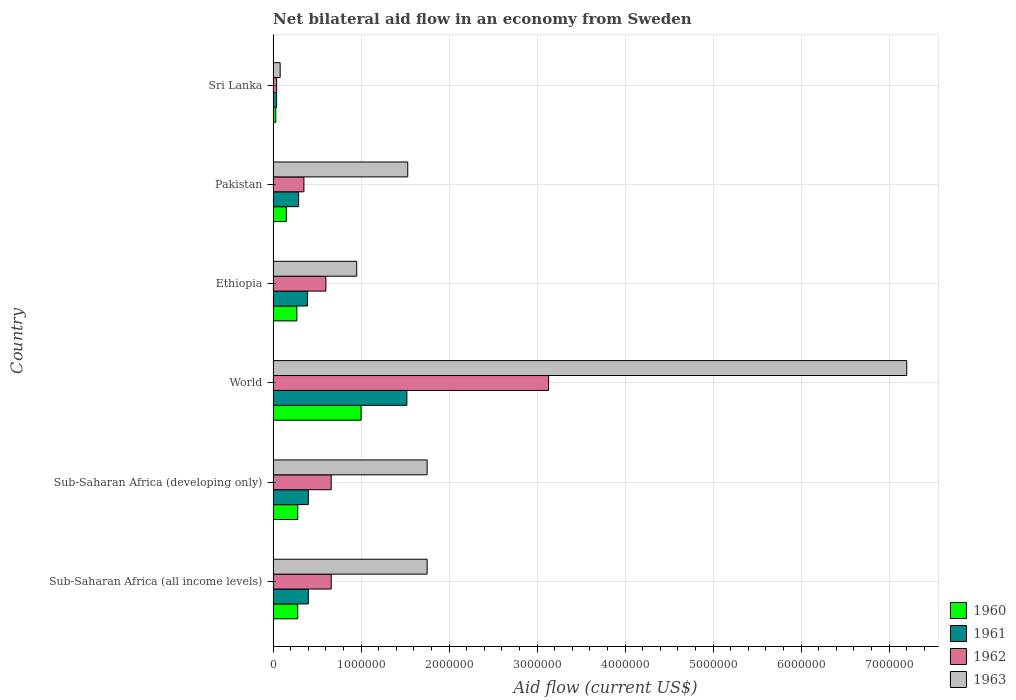How many different coloured bars are there?
Offer a terse response. 4. Are the number of bars per tick equal to the number of legend labels?
Offer a terse response. Yes. What is the label of the 6th group of bars from the top?
Your response must be concise. Sub-Saharan Africa (all income levels). In how many cases, is the number of bars for a given country not equal to the number of legend labels?
Provide a short and direct response. 0. What is the net bilateral aid flow in 1963 in Ethiopia?
Ensure brevity in your answer.  9.50e+05. Across all countries, what is the maximum net bilateral aid flow in 1960?
Make the answer very short. 1.00e+06. In which country was the net bilateral aid flow in 1961 minimum?
Your response must be concise. Sri Lanka. What is the total net bilateral aid flow in 1960 in the graph?
Give a very brief answer. 2.01e+06. What is the difference between the net bilateral aid flow in 1961 in Sri Lanka and that in Sub-Saharan Africa (developing only)?
Make the answer very short. -3.60e+05. What is the difference between the net bilateral aid flow in 1963 in Sri Lanka and the net bilateral aid flow in 1962 in Ethiopia?
Your answer should be compact. -5.20e+05. What is the average net bilateral aid flow in 1960 per country?
Your response must be concise. 3.35e+05. What is the ratio of the net bilateral aid flow in 1960 in Sri Lanka to that in World?
Offer a very short reply. 0.03. Is the difference between the net bilateral aid flow in 1961 in Sri Lanka and World greater than the difference between the net bilateral aid flow in 1960 in Sri Lanka and World?
Give a very brief answer. No. What is the difference between the highest and the second highest net bilateral aid flow in 1962?
Ensure brevity in your answer.  2.47e+06. What is the difference between the highest and the lowest net bilateral aid flow in 1960?
Your answer should be very brief. 9.70e+05. In how many countries, is the net bilateral aid flow in 1962 greater than the average net bilateral aid flow in 1962 taken over all countries?
Make the answer very short. 1. What does the 3rd bar from the bottom in Sub-Saharan Africa (developing only) represents?
Provide a short and direct response. 1962. Is it the case that in every country, the sum of the net bilateral aid flow in 1960 and net bilateral aid flow in 1963 is greater than the net bilateral aid flow in 1962?
Provide a succinct answer. Yes. How many bars are there?
Your answer should be compact. 24. Are all the bars in the graph horizontal?
Keep it short and to the point. Yes. How many countries are there in the graph?
Offer a terse response. 6. What is the difference between two consecutive major ticks on the X-axis?
Make the answer very short. 1.00e+06. Are the values on the major ticks of X-axis written in scientific E-notation?
Your answer should be very brief. No. Does the graph contain any zero values?
Ensure brevity in your answer.  No. Where does the legend appear in the graph?
Your answer should be compact. Bottom right. How are the legend labels stacked?
Keep it short and to the point. Vertical. What is the title of the graph?
Your answer should be compact. Net bilateral aid flow in an economy from Sweden. Does "1990" appear as one of the legend labels in the graph?
Offer a very short reply. No. What is the label or title of the Y-axis?
Give a very brief answer. Country. What is the Aid flow (current US$) in 1962 in Sub-Saharan Africa (all income levels)?
Ensure brevity in your answer.  6.60e+05. What is the Aid flow (current US$) in 1963 in Sub-Saharan Africa (all income levels)?
Provide a short and direct response. 1.75e+06. What is the Aid flow (current US$) in 1960 in Sub-Saharan Africa (developing only)?
Make the answer very short. 2.80e+05. What is the Aid flow (current US$) in 1961 in Sub-Saharan Africa (developing only)?
Provide a short and direct response. 4.00e+05. What is the Aid flow (current US$) in 1963 in Sub-Saharan Africa (developing only)?
Ensure brevity in your answer.  1.75e+06. What is the Aid flow (current US$) of 1960 in World?
Give a very brief answer. 1.00e+06. What is the Aid flow (current US$) of 1961 in World?
Ensure brevity in your answer.  1.52e+06. What is the Aid flow (current US$) in 1962 in World?
Ensure brevity in your answer.  3.13e+06. What is the Aid flow (current US$) in 1963 in World?
Provide a short and direct response. 7.20e+06. What is the Aid flow (current US$) of 1960 in Ethiopia?
Provide a short and direct response. 2.70e+05. What is the Aid flow (current US$) in 1963 in Ethiopia?
Offer a very short reply. 9.50e+05. What is the Aid flow (current US$) of 1963 in Pakistan?
Offer a very short reply. 1.53e+06. Across all countries, what is the maximum Aid flow (current US$) of 1961?
Your answer should be compact. 1.52e+06. Across all countries, what is the maximum Aid flow (current US$) of 1962?
Provide a short and direct response. 3.13e+06. Across all countries, what is the maximum Aid flow (current US$) of 1963?
Offer a very short reply. 7.20e+06. Across all countries, what is the minimum Aid flow (current US$) in 1960?
Provide a succinct answer. 3.00e+04. Across all countries, what is the minimum Aid flow (current US$) in 1961?
Ensure brevity in your answer.  4.00e+04. Across all countries, what is the minimum Aid flow (current US$) in 1963?
Make the answer very short. 8.00e+04. What is the total Aid flow (current US$) of 1960 in the graph?
Offer a terse response. 2.01e+06. What is the total Aid flow (current US$) in 1961 in the graph?
Ensure brevity in your answer.  3.04e+06. What is the total Aid flow (current US$) of 1962 in the graph?
Your response must be concise. 5.44e+06. What is the total Aid flow (current US$) of 1963 in the graph?
Ensure brevity in your answer.  1.33e+07. What is the difference between the Aid flow (current US$) in 1960 in Sub-Saharan Africa (all income levels) and that in Sub-Saharan Africa (developing only)?
Your answer should be compact. 0. What is the difference between the Aid flow (current US$) of 1963 in Sub-Saharan Africa (all income levels) and that in Sub-Saharan Africa (developing only)?
Offer a very short reply. 0. What is the difference between the Aid flow (current US$) of 1960 in Sub-Saharan Africa (all income levels) and that in World?
Keep it short and to the point. -7.20e+05. What is the difference between the Aid flow (current US$) in 1961 in Sub-Saharan Africa (all income levels) and that in World?
Your answer should be very brief. -1.12e+06. What is the difference between the Aid flow (current US$) of 1962 in Sub-Saharan Africa (all income levels) and that in World?
Offer a very short reply. -2.47e+06. What is the difference between the Aid flow (current US$) of 1963 in Sub-Saharan Africa (all income levels) and that in World?
Offer a terse response. -5.45e+06. What is the difference between the Aid flow (current US$) of 1961 in Sub-Saharan Africa (all income levels) and that in Ethiopia?
Offer a terse response. 10000. What is the difference between the Aid flow (current US$) in 1962 in Sub-Saharan Africa (all income levels) and that in Ethiopia?
Keep it short and to the point. 6.00e+04. What is the difference between the Aid flow (current US$) in 1963 in Sub-Saharan Africa (all income levels) and that in Ethiopia?
Offer a very short reply. 8.00e+05. What is the difference between the Aid flow (current US$) in 1961 in Sub-Saharan Africa (all income levels) and that in Sri Lanka?
Give a very brief answer. 3.60e+05. What is the difference between the Aid flow (current US$) in 1962 in Sub-Saharan Africa (all income levels) and that in Sri Lanka?
Offer a very short reply. 6.20e+05. What is the difference between the Aid flow (current US$) in 1963 in Sub-Saharan Africa (all income levels) and that in Sri Lanka?
Make the answer very short. 1.67e+06. What is the difference between the Aid flow (current US$) of 1960 in Sub-Saharan Africa (developing only) and that in World?
Ensure brevity in your answer.  -7.20e+05. What is the difference between the Aid flow (current US$) in 1961 in Sub-Saharan Africa (developing only) and that in World?
Provide a succinct answer. -1.12e+06. What is the difference between the Aid flow (current US$) of 1962 in Sub-Saharan Africa (developing only) and that in World?
Ensure brevity in your answer.  -2.47e+06. What is the difference between the Aid flow (current US$) of 1963 in Sub-Saharan Africa (developing only) and that in World?
Provide a short and direct response. -5.45e+06. What is the difference between the Aid flow (current US$) in 1961 in Sub-Saharan Africa (developing only) and that in Ethiopia?
Your answer should be compact. 10000. What is the difference between the Aid flow (current US$) in 1962 in Sub-Saharan Africa (developing only) and that in Ethiopia?
Provide a succinct answer. 6.00e+04. What is the difference between the Aid flow (current US$) of 1963 in Sub-Saharan Africa (developing only) and that in Ethiopia?
Your answer should be compact. 8.00e+05. What is the difference between the Aid flow (current US$) in 1960 in Sub-Saharan Africa (developing only) and that in Pakistan?
Your answer should be very brief. 1.30e+05. What is the difference between the Aid flow (current US$) of 1962 in Sub-Saharan Africa (developing only) and that in Pakistan?
Keep it short and to the point. 3.10e+05. What is the difference between the Aid flow (current US$) in 1963 in Sub-Saharan Africa (developing only) and that in Pakistan?
Offer a terse response. 2.20e+05. What is the difference between the Aid flow (current US$) of 1962 in Sub-Saharan Africa (developing only) and that in Sri Lanka?
Ensure brevity in your answer.  6.20e+05. What is the difference between the Aid flow (current US$) in 1963 in Sub-Saharan Africa (developing only) and that in Sri Lanka?
Your answer should be compact. 1.67e+06. What is the difference between the Aid flow (current US$) of 1960 in World and that in Ethiopia?
Provide a succinct answer. 7.30e+05. What is the difference between the Aid flow (current US$) in 1961 in World and that in Ethiopia?
Provide a succinct answer. 1.13e+06. What is the difference between the Aid flow (current US$) of 1962 in World and that in Ethiopia?
Give a very brief answer. 2.53e+06. What is the difference between the Aid flow (current US$) of 1963 in World and that in Ethiopia?
Make the answer very short. 6.25e+06. What is the difference between the Aid flow (current US$) in 1960 in World and that in Pakistan?
Your answer should be very brief. 8.50e+05. What is the difference between the Aid flow (current US$) in 1961 in World and that in Pakistan?
Your answer should be very brief. 1.23e+06. What is the difference between the Aid flow (current US$) of 1962 in World and that in Pakistan?
Ensure brevity in your answer.  2.78e+06. What is the difference between the Aid flow (current US$) of 1963 in World and that in Pakistan?
Offer a terse response. 5.67e+06. What is the difference between the Aid flow (current US$) in 1960 in World and that in Sri Lanka?
Keep it short and to the point. 9.70e+05. What is the difference between the Aid flow (current US$) in 1961 in World and that in Sri Lanka?
Offer a terse response. 1.48e+06. What is the difference between the Aid flow (current US$) of 1962 in World and that in Sri Lanka?
Keep it short and to the point. 3.09e+06. What is the difference between the Aid flow (current US$) in 1963 in World and that in Sri Lanka?
Your response must be concise. 7.12e+06. What is the difference between the Aid flow (current US$) of 1960 in Ethiopia and that in Pakistan?
Provide a short and direct response. 1.20e+05. What is the difference between the Aid flow (current US$) in 1963 in Ethiopia and that in Pakistan?
Keep it short and to the point. -5.80e+05. What is the difference between the Aid flow (current US$) in 1960 in Ethiopia and that in Sri Lanka?
Keep it short and to the point. 2.40e+05. What is the difference between the Aid flow (current US$) in 1961 in Ethiopia and that in Sri Lanka?
Make the answer very short. 3.50e+05. What is the difference between the Aid flow (current US$) in 1962 in Ethiopia and that in Sri Lanka?
Provide a succinct answer. 5.60e+05. What is the difference between the Aid flow (current US$) of 1963 in Ethiopia and that in Sri Lanka?
Give a very brief answer. 8.70e+05. What is the difference between the Aid flow (current US$) of 1961 in Pakistan and that in Sri Lanka?
Make the answer very short. 2.50e+05. What is the difference between the Aid flow (current US$) in 1963 in Pakistan and that in Sri Lanka?
Give a very brief answer. 1.45e+06. What is the difference between the Aid flow (current US$) of 1960 in Sub-Saharan Africa (all income levels) and the Aid flow (current US$) of 1961 in Sub-Saharan Africa (developing only)?
Offer a terse response. -1.20e+05. What is the difference between the Aid flow (current US$) of 1960 in Sub-Saharan Africa (all income levels) and the Aid flow (current US$) of 1962 in Sub-Saharan Africa (developing only)?
Provide a short and direct response. -3.80e+05. What is the difference between the Aid flow (current US$) of 1960 in Sub-Saharan Africa (all income levels) and the Aid flow (current US$) of 1963 in Sub-Saharan Africa (developing only)?
Offer a terse response. -1.47e+06. What is the difference between the Aid flow (current US$) of 1961 in Sub-Saharan Africa (all income levels) and the Aid flow (current US$) of 1962 in Sub-Saharan Africa (developing only)?
Give a very brief answer. -2.60e+05. What is the difference between the Aid flow (current US$) in 1961 in Sub-Saharan Africa (all income levels) and the Aid flow (current US$) in 1963 in Sub-Saharan Africa (developing only)?
Make the answer very short. -1.35e+06. What is the difference between the Aid flow (current US$) in 1962 in Sub-Saharan Africa (all income levels) and the Aid flow (current US$) in 1963 in Sub-Saharan Africa (developing only)?
Keep it short and to the point. -1.09e+06. What is the difference between the Aid flow (current US$) in 1960 in Sub-Saharan Africa (all income levels) and the Aid flow (current US$) in 1961 in World?
Ensure brevity in your answer.  -1.24e+06. What is the difference between the Aid flow (current US$) of 1960 in Sub-Saharan Africa (all income levels) and the Aid flow (current US$) of 1962 in World?
Make the answer very short. -2.85e+06. What is the difference between the Aid flow (current US$) of 1960 in Sub-Saharan Africa (all income levels) and the Aid flow (current US$) of 1963 in World?
Provide a short and direct response. -6.92e+06. What is the difference between the Aid flow (current US$) in 1961 in Sub-Saharan Africa (all income levels) and the Aid flow (current US$) in 1962 in World?
Offer a terse response. -2.73e+06. What is the difference between the Aid flow (current US$) of 1961 in Sub-Saharan Africa (all income levels) and the Aid flow (current US$) of 1963 in World?
Give a very brief answer. -6.80e+06. What is the difference between the Aid flow (current US$) in 1962 in Sub-Saharan Africa (all income levels) and the Aid flow (current US$) in 1963 in World?
Offer a very short reply. -6.54e+06. What is the difference between the Aid flow (current US$) in 1960 in Sub-Saharan Africa (all income levels) and the Aid flow (current US$) in 1961 in Ethiopia?
Your answer should be very brief. -1.10e+05. What is the difference between the Aid flow (current US$) in 1960 in Sub-Saharan Africa (all income levels) and the Aid flow (current US$) in 1962 in Ethiopia?
Give a very brief answer. -3.20e+05. What is the difference between the Aid flow (current US$) of 1960 in Sub-Saharan Africa (all income levels) and the Aid flow (current US$) of 1963 in Ethiopia?
Provide a succinct answer. -6.70e+05. What is the difference between the Aid flow (current US$) in 1961 in Sub-Saharan Africa (all income levels) and the Aid flow (current US$) in 1962 in Ethiopia?
Offer a terse response. -2.00e+05. What is the difference between the Aid flow (current US$) of 1961 in Sub-Saharan Africa (all income levels) and the Aid flow (current US$) of 1963 in Ethiopia?
Ensure brevity in your answer.  -5.50e+05. What is the difference between the Aid flow (current US$) of 1960 in Sub-Saharan Africa (all income levels) and the Aid flow (current US$) of 1962 in Pakistan?
Your answer should be very brief. -7.00e+04. What is the difference between the Aid flow (current US$) in 1960 in Sub-Saharan Africa (all income levels) and the Aid flow (current US$) in 1963 in Pakistan?
Provide a short and direct response. -1.25e+06. What is the difference between the Aid flow (current US$) in 1961 in Sub-Saharan Africa (all income levels) and the Aid flow (current US$) in 1963 in Pakistan?
Provide a succinct answer. -1.13e+06. What is the difference between the Aid flow (current US$) of 1962 in Sub-Saharan Africa (all income levels) and the Aid flow (current US$) of 1963 in Pakistan?
Offer a very short reply. -8.70e+05. What is the difference between the Aid flow (current US$) in 1960 in Sub-Saharan Africa (all income levels) and the Aid flow (current US$) in 1961 in Sri Lanka?
Keep it short and to the point. 2.40e+05. What is the difference between the Aid flow (current US$) in 1960 in Sub-Saharan Africa (all income levels) and the Aid flow (current US$) in 1962 in Sri Lanka?
Your response must be concise. 2.40e+05. What is the difference between the Aid flow (current US$) of 1960 in Sub-Saharan Africa (all income levels) and the Aid flow (current US$) of 1963 in Sri Lanka?
Your response must be concise. 2.00e+05. What is the difference between the Aid flow (current US$) of 1961 in Sub-Saharan Africa (all income levels) and the Aid flow (current US$) of 1962 in Sri Lanka?
Give a very brief answer. 3.60e+05. What is the difference between the Aid flow (current US$) of 1962 in Sub-Saharan Africa (all income levels) and the Aid flow (current US$) of 1963 in Sri Lanka?
Provide a succinct answer. 5.80e+05. What is the difference between the Aid flow (current US$) in 1960 in Sub-Saharan Africa (developing only) and the Aid flow (current US$) in 1961 in World?
Your answer should be very brief. -1.24e+06. What is the difference between the Aid flow (current US$) of 1960 in Sub-Saharan Africa (developing only) and the Aid flow (current US$) of 1962 in World?
Keep it short and to the point. -2.85e+06. What is the difference between the Aid flow (current US$) in 1960 in Sub-Saharan Africa (developing only) and the Aid flow (current US$) in 1963 in World?
Keep it short and to the point. -6.92e+06. What is the difference between the Aid flow (current US$) in 1961 in Sub-Saharan Africa (developing only) and the Aid flow (current US$) in 1962 in World?
Your answer should be very brief. -2.73e+06. What is the difference between the Aid flow (current US$) in 1961 in Sub-Saharan Africa (developing only) and the Aid flow (current US$) in 1963 in World?
Your response must be concise. -6.80e+06. What is the difference between the Aid flow (current US$) of 1962 in Sub-Saharan Africa (developing only) and the Aid flow (current US$) of 1963 in World?
Give a very brief answer. -6.54e+06. What is the difference between the Aid flow (current US$) of 1960 in Sub-Saharan Africa (developing only) and the Aid flow (current US$) of 1961 in Ethiopia?
Give a very brief answer. -1.10e+05. What is the difference between the Aid flow (current US$) of 1960 in Sub-Saharan Africa (developing only) and the Aid flow (current US$) of 1962 in Ethiopia?
Provide a short and direct response. -3.20e+05. What is the difference between the Aid flow (current US$) of 1960 in Sub-Saharan Africa (developing only) and the Aid flow (current US$) of 1963 in Ethiopia?
Give a very brief answer. -6.70e+05. What is the difference between the Aid flow (current US$) in 1961 in Sub-Saharan Africa (developing only) and the Aid flow (current US$) in 1962 in Ethiopia?
Offer a very short reply. -2.00e+05. What is the difference between the Aid flow (current US$) of 1961 in Sub-Saharan Africa (developing only) and the Aid flow (current US$) of 1963 in Ethiopia?
Your response must be concise. -5.50e+05. What is the difference between the Aid flow (current US$) in 1962 in Sub-Saharan Africa (developing only) and the Aid flow (current US$) in 1963 in Ethiopia?
Your response must be concise. -2.90e+05. What is the difference between the Aid flow (current US$) of 1960 in Sub-Saharan Africa (developing only) and the Aid flow (current US$) of 1961 in Pakistan?
Your answer should be compact. -10000. What is the difference between the Aid flow (current US$) of 1960 in Sub-Saharan Africa (developing only) and the Aid flow (current US$) of 1962 in Pakistan?
Provide a short and direct response. -7.00e+04. What is the difference between the Aid flow (current US$) in 1960 in Sub-Saharan Africa (developing only) and the Aid flow (current US$) in 1963 in Pakistan?
Your answer should be compact. -1.25e+06. What is the difference between the Aid flow (current US$) in 1961 in Sub-Saharan Africa (developing only) and the Aid flow (current US$) in 1962 in Pakistan?
Ensure brevity in your answer.  5.00e+04. What is the difference between the Aid flow (current US$) of 1961 in Sub-Saharan Africa (developing only) and the Aid flow (current US$) of 1963 in Pakistan?
Your answer should be very brief. -1.13e+06. What is the difference between the Aid flow (current US$) of 1962 in Sub-Saharan Africa (developing only) and the Aid flow (current US$) of 1963 in Pakistan?
Give a very brief answer. -8.70e+05. What is the difference between the Aid flow (current US$) of 1960 in Sub-Saharan Africa (developing only) and the Aid flow (current US$) of 1961 in Sri Lanka?
Make the answer very short. 2.40e+05. What is the difference between the Aid flow (current US$) of 1960 in Sub-Saharan Africa (developing only) and the Aid flow (current US$) of 1962 in Sri Lanka?
Provide a short and direct response. 2.40e+05. What is the difference between the Aid flow (current US$) of 1961 in Sub-Saharan Africa (developing only) and the Aid flow (current US$) of 1962 in Sri Lanka?
Your answer should be compact. 3.60e+05. What is the difference between the Aid flow (current US$) of 1962 in Sub-Saharan Africa (developing only) and the Aid flow (current US$) of 1963 in Sri Lanka?
Give a very brief answer. 5.80e+05. What is the difference between the Aid flow (current US$) in 1960 in World and the Aid flow (current US$) in 1961 in Ethiopia?
Keep it short and to the point. 6.10e+05. What is the difference between the Aid flow (current US$) in 1960 in World and the Aid flow (current US$) in 1963 in Ethiopia?
Your answer should be compact. 5.00e+04. What is the difference between the Aid flow (current US$) of 1961 in World and the Aid flow (current US$) of 1962 in Ethiopia?
Ensure brevity in your answer.  9.20e+05. What is the difference between the Aid flow (current US$) of 1961 in World and the Aid flow (current US$) of 1963 in Ethiopia?
Your answer should be very brief. 5.70e+05. What is the difference between the Aid flow (current US$) in 1962 in World and the Aid flow (current US$) in 1963 in Ethiopia?
Give a very brief answer. 2.18e+06. What is the difference between the Aid flow (current US$) in 1960 in World and the Aid flow (current US$) in 1961 in Pakistan?
Your answer should be very brief. 7.10e+05. What is the difference between the Aid flow (current US$) in 1960 in World and the Aid flow (current US$) in 1962 in Pakistan?
Give a very brief answer. 6.50e+05. What is the difference between the Aid flow (current US$) in 1960 in World and the Aid flow (current US$) in 1963 in Pakistan?
Your response must be concise. -5.30e+05. What is the difference between the Aid flow (current US$) in 1961 in World and the Aid flow (current US$) in 1962 in Pakistan?
Your answer should be compact. 1.17e+06. What is the difference between the Aid flow (current US$) of 1962 in World and the Aid flow (current US$) of 1963 in Pakistan?
Your response must be concise. 1.60e+06. What is the difference between the Aid flow (current US$) in 1960 in World and the Aid flow (current US$) in 1961 in Sri Lanka?
Give a very brief answer. 9.60e+05. What is the difference between the Aid flow (current US$) in 1960 in World and the Aid flow (current US$) in 1962 in Sri Lanka?
Offer a very short reply. 9.60e+05. What is the difference between the Aid flow (current US$) of 1960 in World and the Aid flow (current US$) of 1963 in Sri Lanka?
Your answer should be compact. 9.20e+05. What is the difference between the Aid flow (current US$) in 1961 in World and the Aid flow (current US$) in 1962 in Sri Lanka?
Offer a very short reply. 1.48e+06. What is the difference between the Aid flow (current US$) in 1961 in World and the Aid flow (current US$) in 1963 in Sri Lanka?
Provide a short and direct response. 1.44e+06. What is the difference between the Aid flow (current US$) in 1962 in World and the Aid flow (current US$) in 1963 in Sri Lanka?
Give a very brief answer. 3.05e+06. What is the difference between the Aid flow (current US$) in 1960 in Ethiopia and the Aid flow (current US$) in 1962 in Pakistan?
Ensure brevity in your answer.  -8.00e+04. What is the difference between the Aid flow (current US$) in 1960 in Ethiopia and the Aid flow (current US$) in 1963 in Pakistan?
Provide a succinct answer. -1.26e+06. What is the difference between the Aid flow (current US$) of 1961 in Ethiopia and the Aid flow (current US$) of 1962 in Pakistan?
Provide a succinct answer. 4.00e+04. What is the difference between the Aid flow (current US$) of 1961 in Ethiopia and the Aid flow (current US$) of 1963 in Pakistan?
Offer a terse response. -1.14e+06. What is the difference between the Aid flow (current US$) of 1962 in Ethiopia and the Aid flow (current US$) of 1963 in Pakistan?
Provide a short and direct response. -9.30e+05. What is the difference between the Aid flow (current US$) in 1960 in Ethiopia and the Aid flow (current US$) in 1961 in Sri Lanka?
Make the answer very short. 2.30e+05. What is the difference between the Aid flow (current US$) of 1961 in Ethiopia and the Aid flow (current US$) of 1962 in Sri Lanka?
Give a very brief answer. 3.50e+05. What is the difference between the Aid flow (current US$) in 1961 in Ethiopia and the Aid flow (current US$) in 1963 in Sri Lanka?
Make the answer very short. 3.10e+05. What is the difference between the Aid flow (current US$) in 1962 in Ethiopia and the Aid flow (current US$) in 1963 in Sri Lanka?
Provide a short and direct response. 5.20e+05. What is the difference between the Aid flow (current US$) of 1960 in Pakistan and the Aid flow (current US$) of 1961 in Sri Lanka?
Keep it short and to the point. 1.10e+05. What is the difference between the Aid flow (current US$) of 1961 in Pakistan and the Aid flow (current US$) of 1963 in Sri Lanka?
Provide a succinct answer. 2.10e+05. What is the difference between the Aid flow (current US$) in 1962 in Pakistan and the Aid flow (current US$) in 1963 in Sri Lanka?
Make the answer very short. 2.70e+05. What is the average Aid flow (current US$) of 1960 per country?
Your answer should be compact. 3.35e+05. What is the average Aid flow (current US$) of 1961 per country?
Make the answer very short. 5.07e+05. What is the average Aid flow (current US$) of 1962 per country?
Your answer should be compact. 9.07e+05. What is the average Aid flow (current US$) of 1963 per country?
Ensure brevity in your answer.  2.21e+06. What is the difference between the Aid flow (current US$) of 1960 and Aid flow (current US$) of 1962 in Sub-Saharan Africa (all income levels)?
Keep it short and to the point. -3.80e+05. What is the difference between the Aid flow (current US$) in 1960 and Aid flow (current US$) in 1963 in Sub-Saharan Africa (all income levels)?
Your answer should be compact. -1.47e+06. What is the difference between the Aid flow (current US$) of 1961 and Aid flow (current US$) of 1963 in Sub-Saharan Africa (all income levels)?
Keep it short and to the point. -1.35e+06. What is the difference between the Aid flow (current US$) of 1962 and Aid flow (current US$) of 1963 in Sub-Saharan Africa (all income levels)?
Give a very brief answer. -1.09e+06. What is the difference between the Aid flow (current US$) of 1960 and Aid flow (current US$) of 1962 in Sub-Saharan Africa (developing only)?
Your response must be concise. -3.80e+05. What is the difference between the Aid flow (current US$) in 1960 and Aid flow (current US$) in 1963 in Sub-Saharan Africa (developing only)?
Your answer should be compact. -1.47e+06. What is the difference between the Aid flow (current US$) of 1961 and Aid flow (current US$) of 1962 in Sub-Saharan Africa (developing only)?
Ensure brevity in your answer.  -2.60e+05. What is the difference between the Aid flow (current US$) in 1961 and Aid flow (current US$) in 1963 in Sub-Saharan Africa (developing only)?
Ensure brevity in your answer.  -1.35e+06. What is the difference between the Aid flow (current US$) of 1962 and Aid flow (current US$) of 1963 in Sub-Saharan Africa (developing only)?
Ensure brevity in your answer.  -1.09e+06. What is the difference between the Aid flow (current US$) in 1960 and Aid flow (current US$) in 1961 in World?
Your answer should be compact. -5.20e+05. What is the difference between the Aid flow (current US$) in 1960 and Aid flow (current US$) in 1962 in World?
Your answer should be very brief. -2.13e+06. What is the difference between the Aid flow (current US$) of 1960 and Aid flow (current US$) of 1963 in World?
Make the answer very short. -6.20e+06. What is the difference between the Aid flow (current US$) in 1961 and Aid flow (current US$) in 1962 in World?
Keep it short and to the point. -1.61e+06. What is the difference between the Aid flow (current US$) of 1961 and Aid flow (current US$) of 1963 in World?
Give a very brief answer. -5.68e+06. What is the difference between the Aid flow (current US$) in 1962 and Aid flow (current US$) in 1963 in World?
Offer a very short reply. -4.07e+06. What is the difference between the Aid flow (current US$) in 1960 and Aid flow (current US$) in 1961 in Ethiopia?
Your answer should be very brief. -1.20e+05. What is the difference between the Aid flow (current US$) in 1960 and Aid flow (current US$) in 1962 in Ethiopia?
Provide a short and direct response. -3.30e+05. What is the difference between the Aid flow (current US$) in 1960 and Aid flow (current US$) in 1963 in Ethiopia?
Keep it short and to the point. -6.80e+05. What is the difference between the Aid flow (current US$) in 1961 and Aid flow (current US$) in 1963 in Ethiopia?
Your response must be concise. -5.60e+05. What is the difference between the Aid flow (current US$) of 1962 and Aid flow (current US$) of 1963 in Ethiopia?
Give a very brief answer. -3.50e+05. What is the difference between the Aid flow (current US$) in 1960 and Aid flow (current US$) in 1963 in Pakistan?
Provide a short and direct response. -1.38e+06. What is the difference between the Aid flow (current US$) in 1961 and Aid flow (current US$) in 1963 in Pakistan?
Your answer should be compact. -1.24e+06. What is the difference between the Aid flow (current US$) of 1962 and Aid flow (current US$) of 1963 in Pakistan?
Your answer should be very brief. -1.18e+06. What is the difference between the Aid flow (current US$) in 1960 and Aid flow (current US$) in 1962 in Sri Lanka?
Your answer should be very brief. -10000. What is the difference between the Aid flow (current US$) of 1961 and Aid flow (current US$) of 1963 in Sri Lanka?
Give a very brief answer. -4.00e+04. What is the ratio of the Aid flow (current US$) in 1961 in Sub-Saharan Africa (all income levels) to that in Sub-Saharan Africa (developing only)?
Offer a terse response. 1. What is the ratio of the Aid flow (current US$) in 1960 in Sub-Saharan Africa (all income levels) to that in World?
Ensure brevity in your answer.  0.28. What is the ratio of the Aid flow (current US$) in 1961 in Sub-Saharan Africa (all income levels) to that in World?
Give a very brief answer. 0.26. What is the ratio of the Aid flow (current US$) of 1962 in Sub-Saharan Africa (all income levels) to that in World?
Offer a terse response. 0.21. What is the ratio of the Aid flow (current US$) of 1963 in Sub-Saharan Africa (all income levels) to that in World?
Make the answer very short. 0.24. What is the ratio of the Aid flow (current US$) of 1960 in Sub-Saharan Africa (all income levels) to that in Ethiopia?
Ensure brevity in your answer.  1.04. What is the ratio of the Aid flow (current US$) of 1961 in Sub-Saharan Africa (all income levels) to that in Ethiopia?
Offer a very short reply. 1.03. What is the ratio of the Aid flow (current US$) in 1963 in Sub-Saharan Africa (all income levels) to that in Ethiopia?
Offer a terse response. 1.84. What is the ratio of the Aid flow (current US$) in 1960 in Sub-Saharan Africa (all income levels) to that in Pakistan?
Make the answer very short. 1.87. What is the ratio of the Aid flow (current US$) in 1961 in Sub-Saharan Africa (all income levels) to that in Pakistan?
Your response must be concise. 1.38. What is the ratio of the Aid flow (current US$) in 1962 in Sub-Saharan Africa (all income levels) to that in Pakistan?
Your response must be concise. 1.89. What is the ratio of the Aid flow (current US$) in 1963 in Sub-Saharan Africa (all income levels) to that in Pakistan?
Ensure brevity in your answer.  1.14. What is the ratio of the Aid flow (current US$) in 1960 in Sub-Saharan Africa (all income levels) to that in Sri Lanka?
Give a very brief answer. 9.33. What is the ratio of the Aid flow (current US$) in 1961 in Sub-Saharan Africa (all income levels) to that in Sri Lanka?
Your response must be concise. 10. What is the ratio of the Aid flow (current US$) in 1963 in Sub-Saharan Africa (all income levels) to that in Sri Lanka?
Your answer should be very brief. 21.88. What is the ratio of the Aid flow (current US$) in 1960 in Sub-Saharan Africa (developing only) to that in World?
Provide a succinct answer. 0.28. What is the ratio of the Aid flow (current US$) in 1961 in Sub-Saharan Africa (developing only) to that in World?
Keep it short and to the point. 0.26. What is the ratio of the Aid flow (current US$) of 1962 in Sub-Saharan Africa (developing only) to that in World?
Give a very brief answer. 0.21. What is the ratio of the Aid flow (current US$) in 1963 in Sub-Saharan Africa (developing only) to that in World?
Keep it short and to the point. 0.24. What is the ratio of the Aid flow (current US$) of 1961 in Sub-Saharan Africa (developing only) to that in Ethiopia?
Offer a very short reply. 1.03. What is the ratio of the Aid flow (current US$) in 1963 in Sub-Saharan Africa (developing only) to that in Ethiopia?
Provide a succinct answer. 1.84. What is the ratio of the Aid flow (current US$) in 1960 in Sub-Saharan Africa (developing only) to that in Pakistan?
Your answer should be very brief. 1.87. What is the ratio of the Aid flow (current US$) of 1961 in Sub-Saharan Africa (developing only) to that in Pakistan?
Provide a succinct answer. 1.38. What is the ratio of the Aid flow (current US$) in 1962 in Sub-Saharan Africa (developing only) to that in Pakistan?
Ensure brevity in your answer.  1.89. What is the ratio of the Aid flow (current US$) in 1963 in Sub-Saharan Africa (developing only) to that in Pakistan?
Ensure brevity in your answer.  1.14. What is the ratio of the Aid flow (current US$) in 1960 in Sub-Saharan Africa (developing only) to that in Sri Lanka?
Provide a succinct answer. 9.33. What is the ratio of the Aid flow (current US$) of 1962 in Sub-Saharan Africa (developing only) to that in Sri Lanka?
Ensure brevity in your answer.  16.5. What is the ratio of the Aid flow (current US$) in 1963 in Sub-Saharan Africa (developing only) to that in Sri Lanka?
Ensure brevity in your answer.  21.88. What is the ratio of the Aid flow (current US$) of 1960 in World to that in Ethiopia?
Your answer should be compact. 3.7. What is the ratio of the Aid flow (current US$) in 1961 in World to that in Ethiopia?
Your answer should be compact. 3.9. What is the ratio of the Aid flow (current US$) of 1962 in World to that in Ethiopia?
Keep it short and to the point. 5.22. What is the ratio of the Aid flow (current US$) in 1963 in World to that in Ethiopia?
Your answer should be very brief. 7.58. What is the ratio of the Aid flow (current US$) of 1960 in World to that in Pakistan?
Provide a succinct answer. 6.67. What is the ratio of the Aid flow (current US$) of 1961 in World to that in Pakistan?
Make the answer very short. 5.24. What is the ratio of the Aid flow (current US$) of 1962 in World to that in Pakistan?
Give a very brief answer. 8.94. What is the ratio of the Aid flow (current US$) in 1963 in World to that in Pakistan?
Provide a short and direct response. 4.71. What is the ratio of the Aid flow (current US$) in 1960 in World to that in Sri Lanka?
Your response must be concise. 33.33. What is the ratio of the Aid flow (current US$) of 1962 in World to that in Sri Lanka?
Offer a terse response. 78.25. What is the ratio of the Aid flow (current US$) in 1960 in Ethiopia to that in Pakistan?
Your response must be concise. 1.8. What is the ratio of the Aid flow (current US$) in 1961 in Ethiopia to that in Pakistan?
Give a very brief answer. 1.34. What is the ratio of the Aid flow (current US$) of 1962 in Ethiopia to that in Pakistan?
Give a very brief answer. 1.71. What is the ratio of the Aid flow (current US$) of 1963 in Ethiopia to that in Pakistan?
Keep it short and to the point. 0.62. What is the ratio of the Aid flow (current US$) of 1960 in Ethiopia to that in Sri Lanka?
Your answer should be compact. 9. What is the ratio of the Aid flow (current US$) of 1961 in Ethiopia to that in Sri Lanka?
Give a very brief answer. 9.75. What is the ratio of the Aid flow (current US$) in 1962 in Ethiopia to that in Sri Lanka?
Provide a short and direct response. 15. What is the ratio of the Aid flow (current US$) in 1963 in Ethiopia to that in Sri Lanka?
Offer a terse response. 11.88. What is the ratio of the Aid flow (current US$) of 1960 in Pakistan to that in Sri Lanka?
Your answer should be very brief. 5. What is the ratio of the Aid flow (current US$) of 1961 in Pakistan to that in Sri Lanka?
Provide a succinct answer. 7.25. What is the ratio of the Aid flow (current US$) of 1962 in Pakistan to that in Sri Lanka?
Your answer should be compact. 8.75. What is the ratio of the Aid flow (current US$) of 1963 in Pakistan to that in Sri Lanka?
Give a very brief answer. 19.12. What is the difference between the highest and the second highest Aid flow (current US$) of 1960?
Ensure brevity in your answer.  7.20e+05. What is the difference between the highest and the second highest Aid flow (current US$) of 1961?
Your answer should be compact. 1.12e+06. What is the difference between the highest and the second highest Aid flow (current US$) of 1962?
Ensure brevity in your answer.  2.47e+06. What is the difference between the highest and the second highest Aid flow (current US$) in 1963?
Provide a succinct answer. 5.45e+06. What is the difference between the highest and the lowest Aid flow (current US$) of 1960?
Ensure brevity in your answer.  9.70e+05. What is the difference between the highest and the lowest Aid flow (current US$) of 1961?
Offer a very short reply. 1.48e+06. What is the difference between the highest and the lowest Aid flow (current US$) of 1962?
Make the answer very short. 3.09e+06. What is the difference between the highest and the lowest Aid flow (current US$) in 1963?
Your answer should be very brief. 7.12e+06. 